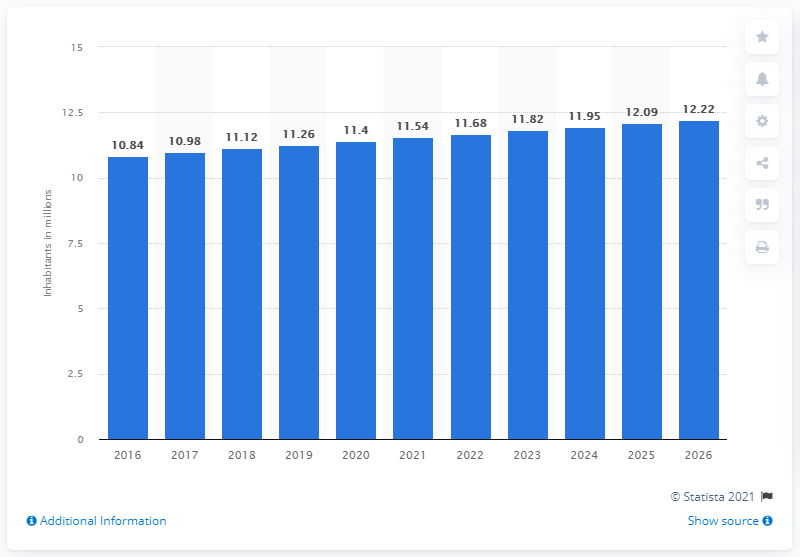Outline some significant characteristics in this image. In 2019, the population of Haiti was 11.26 million. 